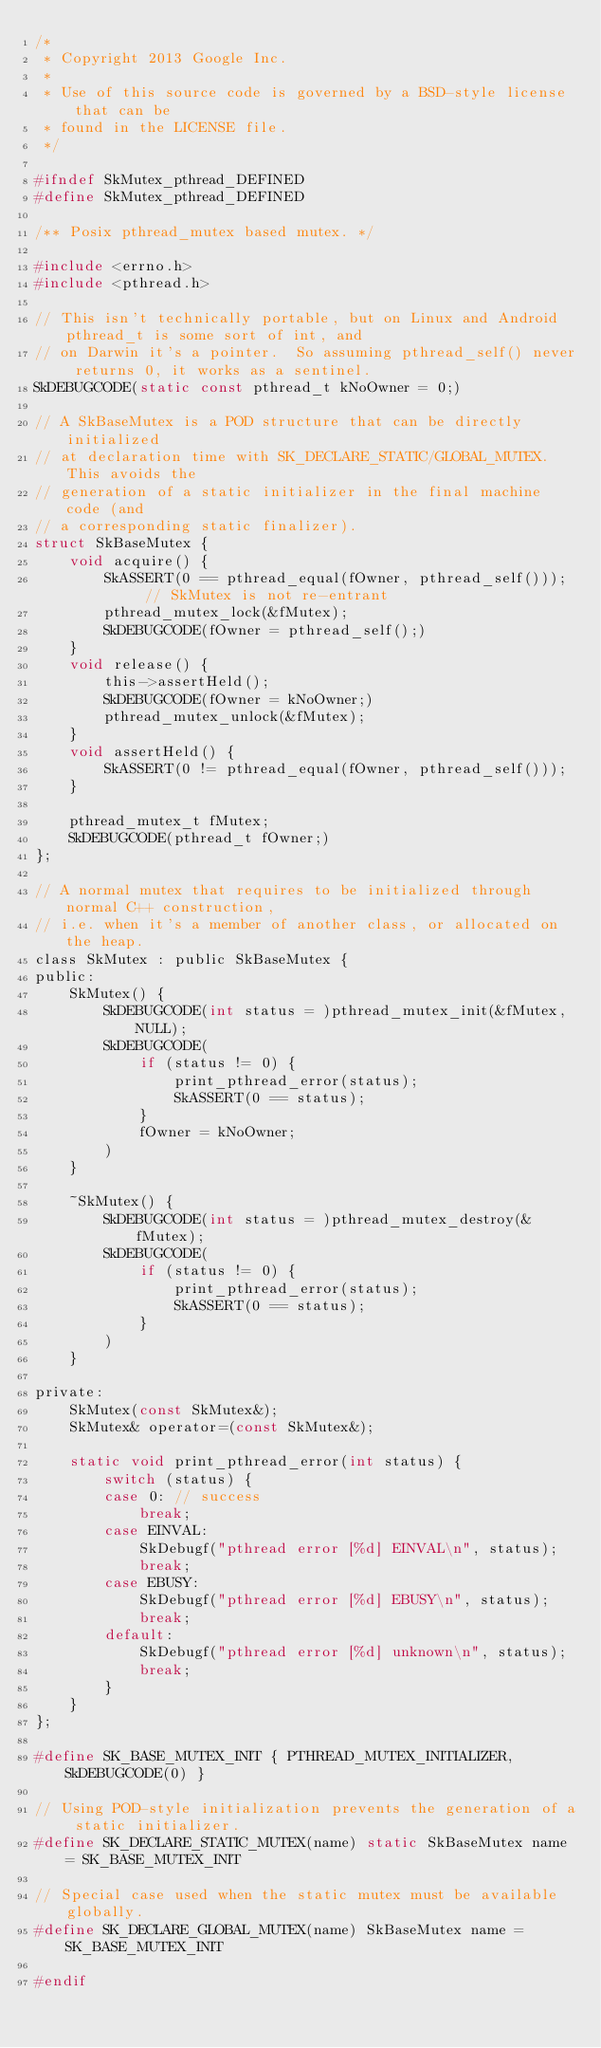Convert code to text. <code><loc_0><loc_0><loc_500><loc_500><_C_>/*
 * Copyright 2013 Google Inc.
 *
 * Use of this source code is governed by a BSD-style license that can be
 * found in the LICENSE file.
 */

#ifndef SkMutex_pthread_DEFINED
#define SkMutex_pthread_DEFINED

/** Posix pthread_mutex based mutex. */

#include <errno.h>
#include <pthread.h>

// This isn't technically portable, but on Linux and Android pthread_t is some sort of int, and
// on Darwin it's a pointer.  So assuming pthread_self() never returns 0, it works as a sentinel.
SkDEBUGCODE(static const pthread_t kNoOwner = 0;)

// A SkBaseMutex is a POD structure that can be directly initialized
// at declaration time with SK_DECLARE_STATIC/GLOBAL_MUTEX. This avoids the
// generation of a static initializer in the final machine code (and
// a corresponding static finalizer).
struct SkBaseMutex {
    void acquire() {
        SkASSERT(0 == pthread_equal(fOwner, pthread_self()));  // SkMutex is not re-entrant
        pthread_mutex_lock(&fMutex);
        SkDEBUGCODE(fOwner = pthread_self();)
    }
    void release() {
        this->assertHeld();
        SkDEBUGCODE(fOwner = kNoOwner;)
        pthread_mutex_unlock(&fMutex);
    }
    void assertHeld() {
        SkASSERT(0 != pthread_equal(fOwner, pthread_self()));
    }

    pthread_mutex_t fMutex;
    SkDEBUGCODE(pthread_t fOwner;)
};

// A normal mutex that requires to be initialized through normal C++ construction,
// i.e. when it's a member of another class, or allocated on the heap.
class SkMutex : public SkBaseMutex {
public:
    SkMutex() {
        SkDEBUGCODE(int status = )pthread_mutex_init(&fMutex, NULL);
        SkDEBUGCODE(
            if (status != 0) {
                print_pthread_error(status);
                SkASSERT(0 == status);
            }
            fOwner = kNoOwner;
        )
    }

    ~SkMutex() {
        SkDEBUGCODE(int status = )pthread_mutex_destroy(&fMutex);
        SkDEBUGCODE(
            if (status != 0) {
                print_pthread_error(status);
                SkASSERT(0 == status);
            }
        )
    }

private:
    SkMutex(const SkMutex&);
    SkMutex& operator=(const SkMutex&);

    static void print_pthread_error(int status) {
        switch (status) {
        case 0: // success
            break;
        case EINVAL:
            SkDebugf("pthread error [%d] EINVAL\n", status);
            break;
        case EBUSY:
            SkDebugf("pthread error [%d] EBUSY\n", status);
            break;
        default:
            SkDebugf("pthread error [%d] unknown\n", status);
            break;
        }
    }
};

#define SK_BASE_MUTEX_INIT { PTHREAD_MUTEX_INITIALIZER, SkDEBUGCODE(0) }

// Using POD-style initialization prevents the generation of a static initializer.
#define SK_DECLARE_STATIC_MUTEX(name) static SkBaseMutex name = SK_BASE_MUTEX_INIT

// Special case used when the static mutex must be available globally.
#define SK_DECLARE_GLOBAL_MUTEX(name) SkBaseMutex name = SK_BASE_MUTEX_INIT

#endif
</code> 